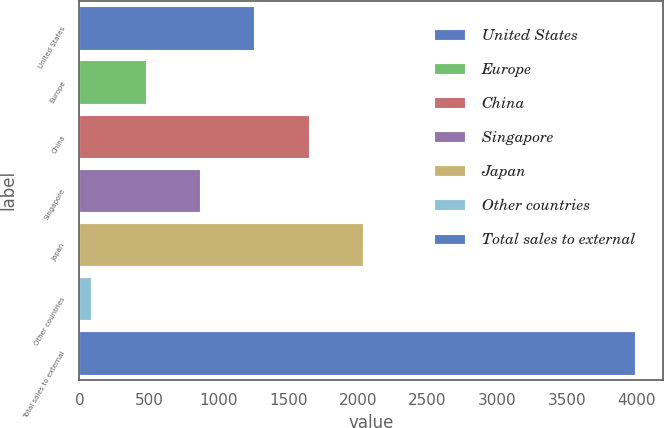<chart> <loc_0><loc_0><loc_500><loc_500><bar_chart><fcel>United States<fcel>Europe<fcel>China<fcel>Singapore<fcel>Japan<fcel>Other countries<fcel>Total sales to external<nl><fcel>1256.1<fcel>474.7<fcel>1646.8<fcel>865.4<fcel>2037.5<fcel>84<fcel>3991<nl></chart> 